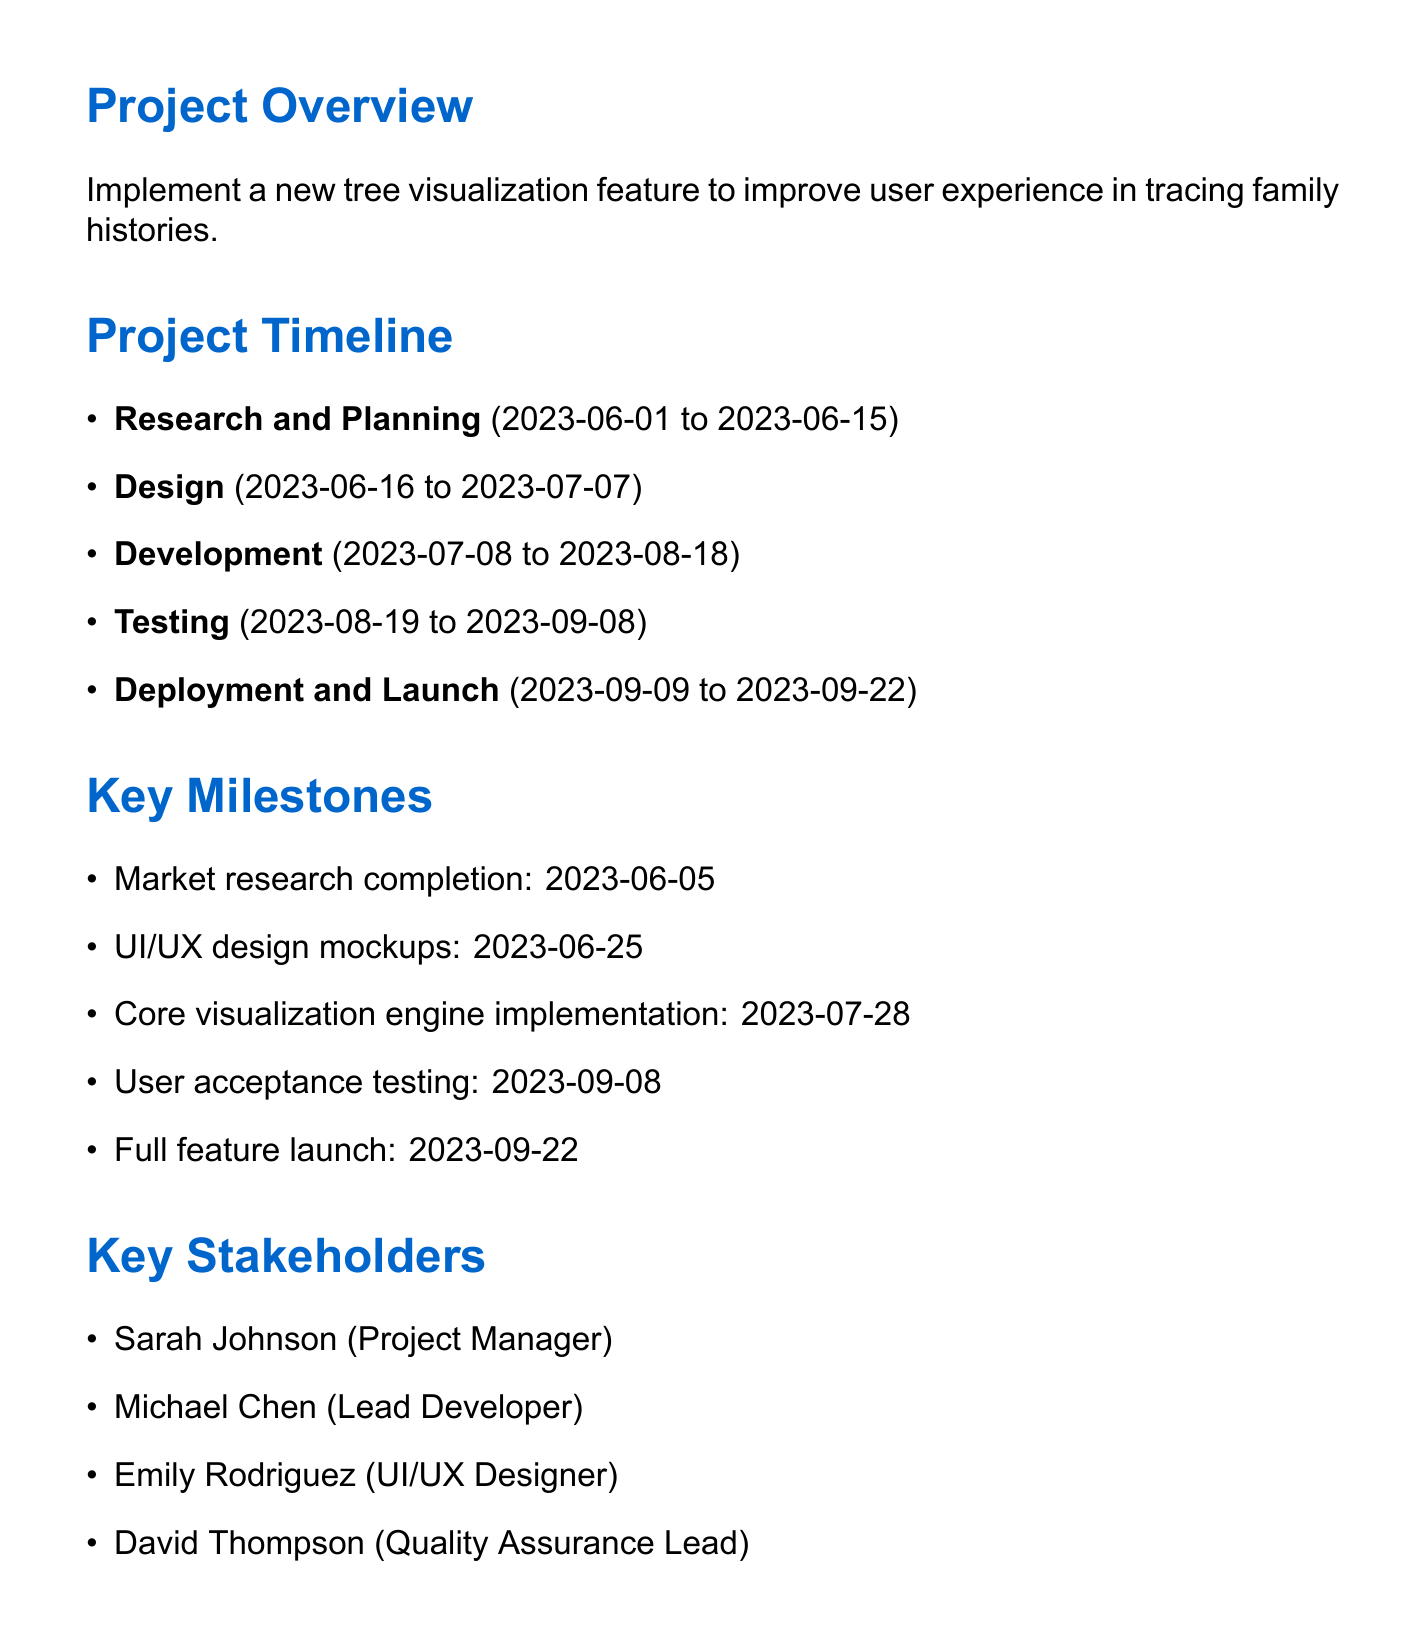What is the project name? The project name is clearly stated in the document as the title of the project.
Answer: Family Tree Visualization Enhancement What is the end date of the Development phase? The end date for the Development phase is found in the timeline section of the document.
Answer: 2023-08-18 How many key stakeholders are there? The total number of key stakeholders is mentioned in the list provided.
Answer: 4 What is the deadline for User acceptance testing? The deadline for User acceptance testing is specified under the Testing milestones in the document.
Answer: 2023-09-08 What risk factor addresses performance issues? The document lists various risk factors along with their mitigations.
Answer: Performance issues with large family trees What is the target percentage increase in user engagement? The success metrics section outlines target increases, including user engagement goals.
Answer: 30% What is the deadline for the Beta release to select users? This information is found in the Deployment and Launch milestones section of the document.
Answer: 2023-09-15 What will be integrated for advanced tree rendering? The technical considerations section specifies the tools and technologies to be integrated for visualization.
Answer: D3.js What is the duration of the Testing phase? The duration can be calculated based on the start and end dates provided for the Testing phase.
Answer: 21 days 